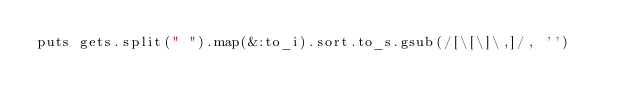<code> <loc_0><loc_0><loc_500><loc_500><_Ruby_>puts gets.split(" ").map(&:to_i).sort.to_s.gsub(/[\[\]\,]/, '')</code> 